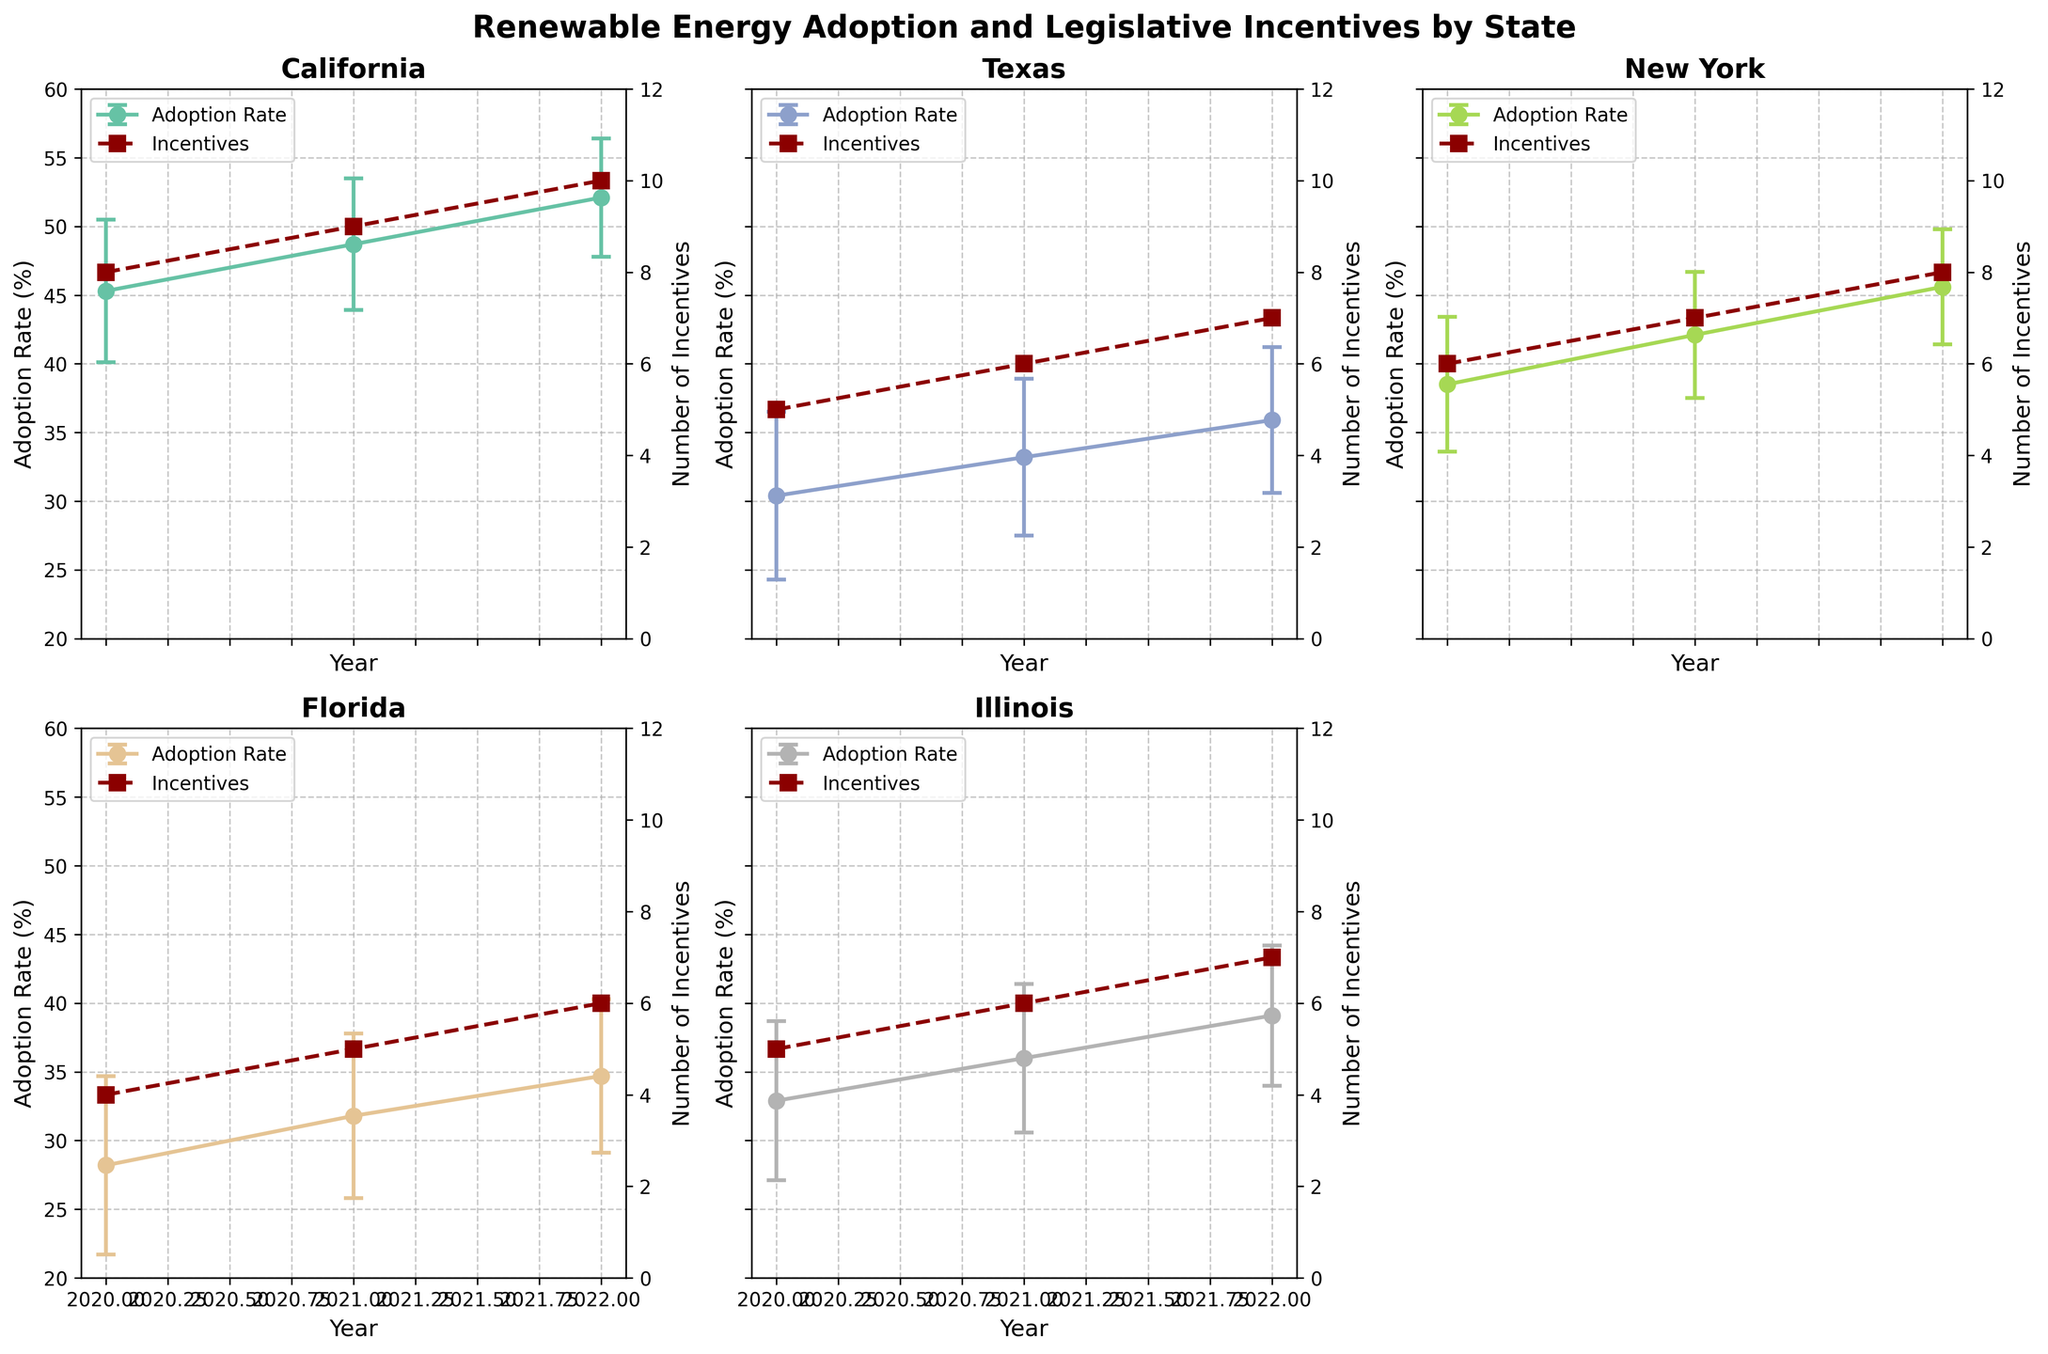What is the range of the adoption rate percentages shown for California in 2022? The adoption rate percentage for California in 2022 is given as 52.1% with an error bar (standard deviation) of ±4.3%. Therefore, the range is from 52.1% - 4.3% to 52.1% + 4.3%.
Answer: 47.8% to 56.4% Which state had the highest renewable energy adoption rate in 2022? By examining the data, California has the highest adoption rate in 2022 with a value of 52.1%.
Answer: California How does the number of legislative incentives in Texas in 2021 compare to that in 2020? Texas had 5 incentives in 2020 and 6 incentives in 2021. The number of incentives increased by 1.
Answer: Increased by 1 Which state shows the smallest variability in renewable energy adoption rates in 2022? The variability is represented by the standard deviation. In 2022, the smallest standard deviation among the states is that of Illinois, which is 5.1%.
Answer: Illinois How did the adoption rate change for New York from 2020 to 2022? In 2020, New York's adoption rate was 38.5%, and in 2022, it was 45.6%. The change is 45.6% - 38.5% = 7.1%.
Answer: Increased by 7.1% Which state had more incentives in 2022, Florida or Illinois? In 2022, Florida had 6 incentives, while Illinois had 7 incentives, so Illinois had more incentives.
Answer: Illinois What is the trend in renewable energy adoption rate in California from 2020 to 2022? From 2020 to 2022, the adoption rate in California increased each year. Specifically, it went from 45.3% in 2020 to 48.7% in 2021, and then to 52.1% in 2022.
Answer: Increasing Which state shows the largest increase in renewable energy adoption rate from 2020 to 2022? Calculating the increases from 2020 to 2022 for all states: 
- California: 52.1% - 45.3% = 6.8%
- Texas: 35.9% - 30.4% = 5.5%
- New York: 45.6% - 38.5% = 7.1%
- Florida: 34.7% - 28.2% = 6.5%
- Illinois: 39.1% - 32.9% = 6.2%
New York shows the largest increase of 7.1%.
Answer: New York What are the standard deviations in the adoption rates for Texas in 2022 and New York in 2022? The standard deviation for Texas in 2022 is 5.3%, and for New York, it is 4.2%.
Answer: Texas: 5.3%, New York: 4.2% 